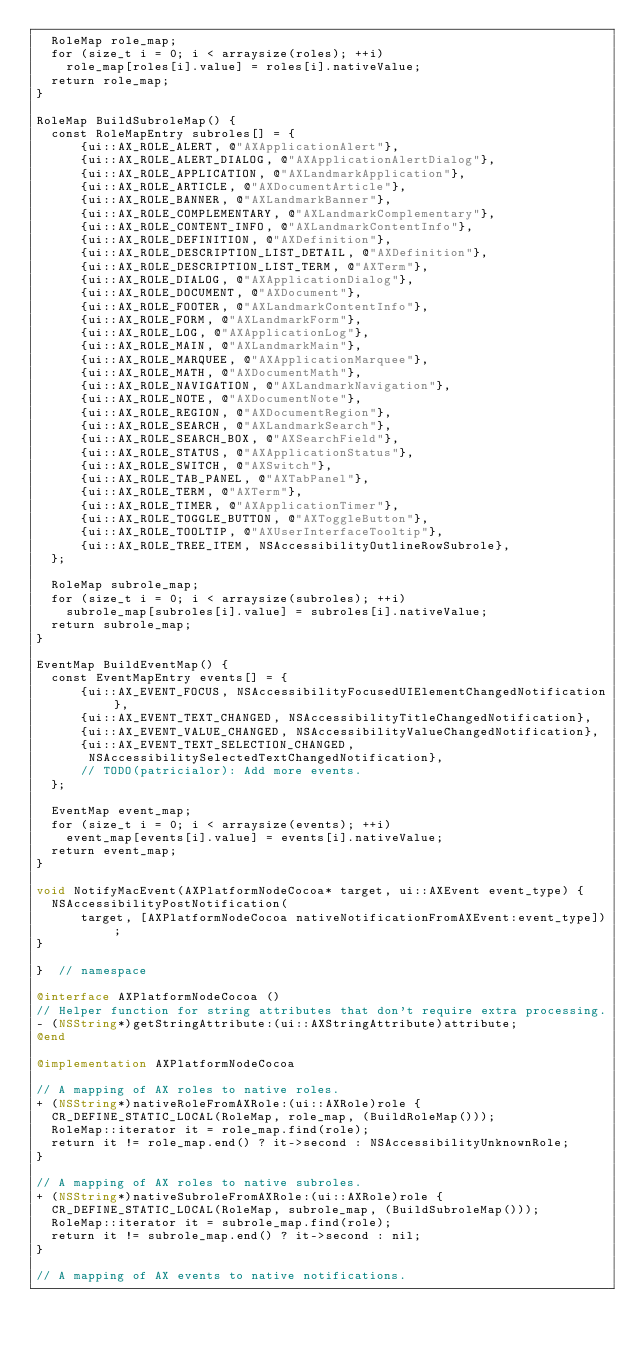Convert code to text. <code><loc_0><loc_0><loc_500><loc_500><_ObjectiveC_>  RoleMap role_map;
  for (size_t i = 0; i < arraysize(roles); ++i)
    role_map[roles[i].value] = roles[i].nativeValue;
  return role_map;
}

RoleMap BuildSubroleMap() {
  const RoleMapEntry subroles[] = {
      {ui::AX_ROLE_ALERT, @"AXApplicationAlert"},
      {ui::AX_ROLE_ALERT_DIALOG, @"AXApplicationAlertDialog"},
      {ui::AX_ROLE_APPLICATION, @"AXLandmarkApplication"},
      {ui::AX_ROLE_ARTICLE, @"AXDocumentArticle"},
      {ui::AX_ROLE_BANNER, @"AXLandmarkBanner"},
      {ui::AX_ROLE_COMPLEMENTARY, @"AXLandmarkComplementary"},
      {ui::AX_ROLE_CONTENT_INFO, @"AXLandmarkContentInfo"},
      {ui::AX_ROLE_DEFINITION, @"AXDefinition"},
      {ui::AX_ROLE_DESCRIPTION_LIST_DETAIL, @"AXDefinition"},
      {ui::AX_ROLE_DESCRIPTION_LIST_TERM, @"AXTerm"},
      {ui::AX_ROLE_DIALOG, @"AXApplicationDialog"},
      {ui::AX_ROLE_DOCUMENT, @"AXDocument"},
      {ui::AX_ROLE_FOOTER, @"AXLandmarkContentInfo"},
      {ui::AX_ROLE_FORM, @"AXLandmarkForm"},
      {ui::AX_ROLE_LOG, @"AXApplicationLog"},
      {ui::AX_ROLE_MAIN, @"AXLandmarkMain"},
      {ui::AX_ROLE_MARQUEE, @"AXApplicationMarquee"},
      {ui::AX_ROLE_MATH, @"AXDocumentMath"},
      {ui::AX_ROLE_NAVIGATION, @"AXLandmarkNavigation"},
      {ui::AX_ROLE_NOTE, @"AXDocumentNote"},
      {ui::AX_ROLE_REGION, @"AXDocumentRegion"},
      {ui::AX_ROLE_SEARCH, @"AXLandmarkSearch"},
      {ui::AX_ROLE_SEARCH_BOX, @"AXSearchField"},
      {ui::AX_ROLE_STATUS, @"AXApplicationStatus"},
      {ui::AX_ROLE_SWITCH, @"AXSwitch"},
      {ui::AX_ROLE_TAB_PANEL, @"AXTabPanel"},
      {ui::AX_ROLE_TERM, @"AXTerm"},
      {ui::AX_ROLE_TIMER, @"AXApplicationTimer"},
      {ui::AX_ROLE_TOGGLE_BUTTON, @"AXToggleButton"},
      {ui::AX_ROLE_TOOLTIP, @"AXUserInterfaceTooltip"},
      {ui::AX_ROLE_TREE_ITEM, NSAccessibilityOutlineRowSubrole},
  };

  RoleMap subrole_map;
  for (size_t i = 0; i < arraysize(subroles); ++i)
    subrole_map[subroles[i].value] = subroles[i].nativeValue;
  return subrole_map;
}

EventMap BuildEventMap() {
  const EventMapEntry events[] = {
      {ui::AX_EVENT_FOCUS, NSAccessibilityFocusedUIElementChangedNotification},
      {ui::AX_EVENT_TEXT_CHANGED, NSAccessibilityTitleChangedNotification},
      {ui::AX_EVENT_VALUE_CHANGED, NSAccessibilityValueChangedNotification},
      {ui::AX_EVENT_TEXT_SELECTION_CHANGED,
       NSAccessibilitySelectedTextChangedNotification},
      // TODO(patricialor): Add more events.
  };

  EventMap event_map;
  for (size_t i = 0; i < arraysize(events); ++i)
    event_map[events[i].value] = events[i].nativeValue;
  return event_map;
}

void NotifyMacEvent(AXPlatformNodeCocoa* target, ui::AXEvent event_type) {
  NSAccessibilityPostNotification(
      target, [AXPlatformNodeCocoa nativeNotificationFromAXEvent:event_type]);
}

}  // namespace

@interface AXPlatformNodeCocoa ()
// Helper function for string attributes that don't require extra processing.
- (NSString*)getStringAttribute:(ui::AXStringAttribute)attribute;
@end

@implementation AXPlatformNodeCocoa

// A mapping of AX roles to native roles.
+ (NSString*)nativeRoleFromAXRole:(ui::AXRole)role {
  CR_DEFINE_STATIC_LOCAL(RoleMap, role_map, (BuildRoleMap()));
  RoleMap::iterator it = role_map.find(role);
  return it != role_map.end() ? it->second : NSAccessibilityUnknownRole;
}

// A mapping of AX roles to native subroles.
+ (NSString*)nativeSubroleFromAXRole:(ui::AXRole)role {
  CR_DEFINE_STATIC_LOCAL(RoleMap, subrole_map, (BuildSubroleMap()));
  RoleMap::iterator it = subrole_map.find(role);
  return it != subrole_map.end() ? it->second : nil;
}

// A mapping of AX events to native notifications.</code> 